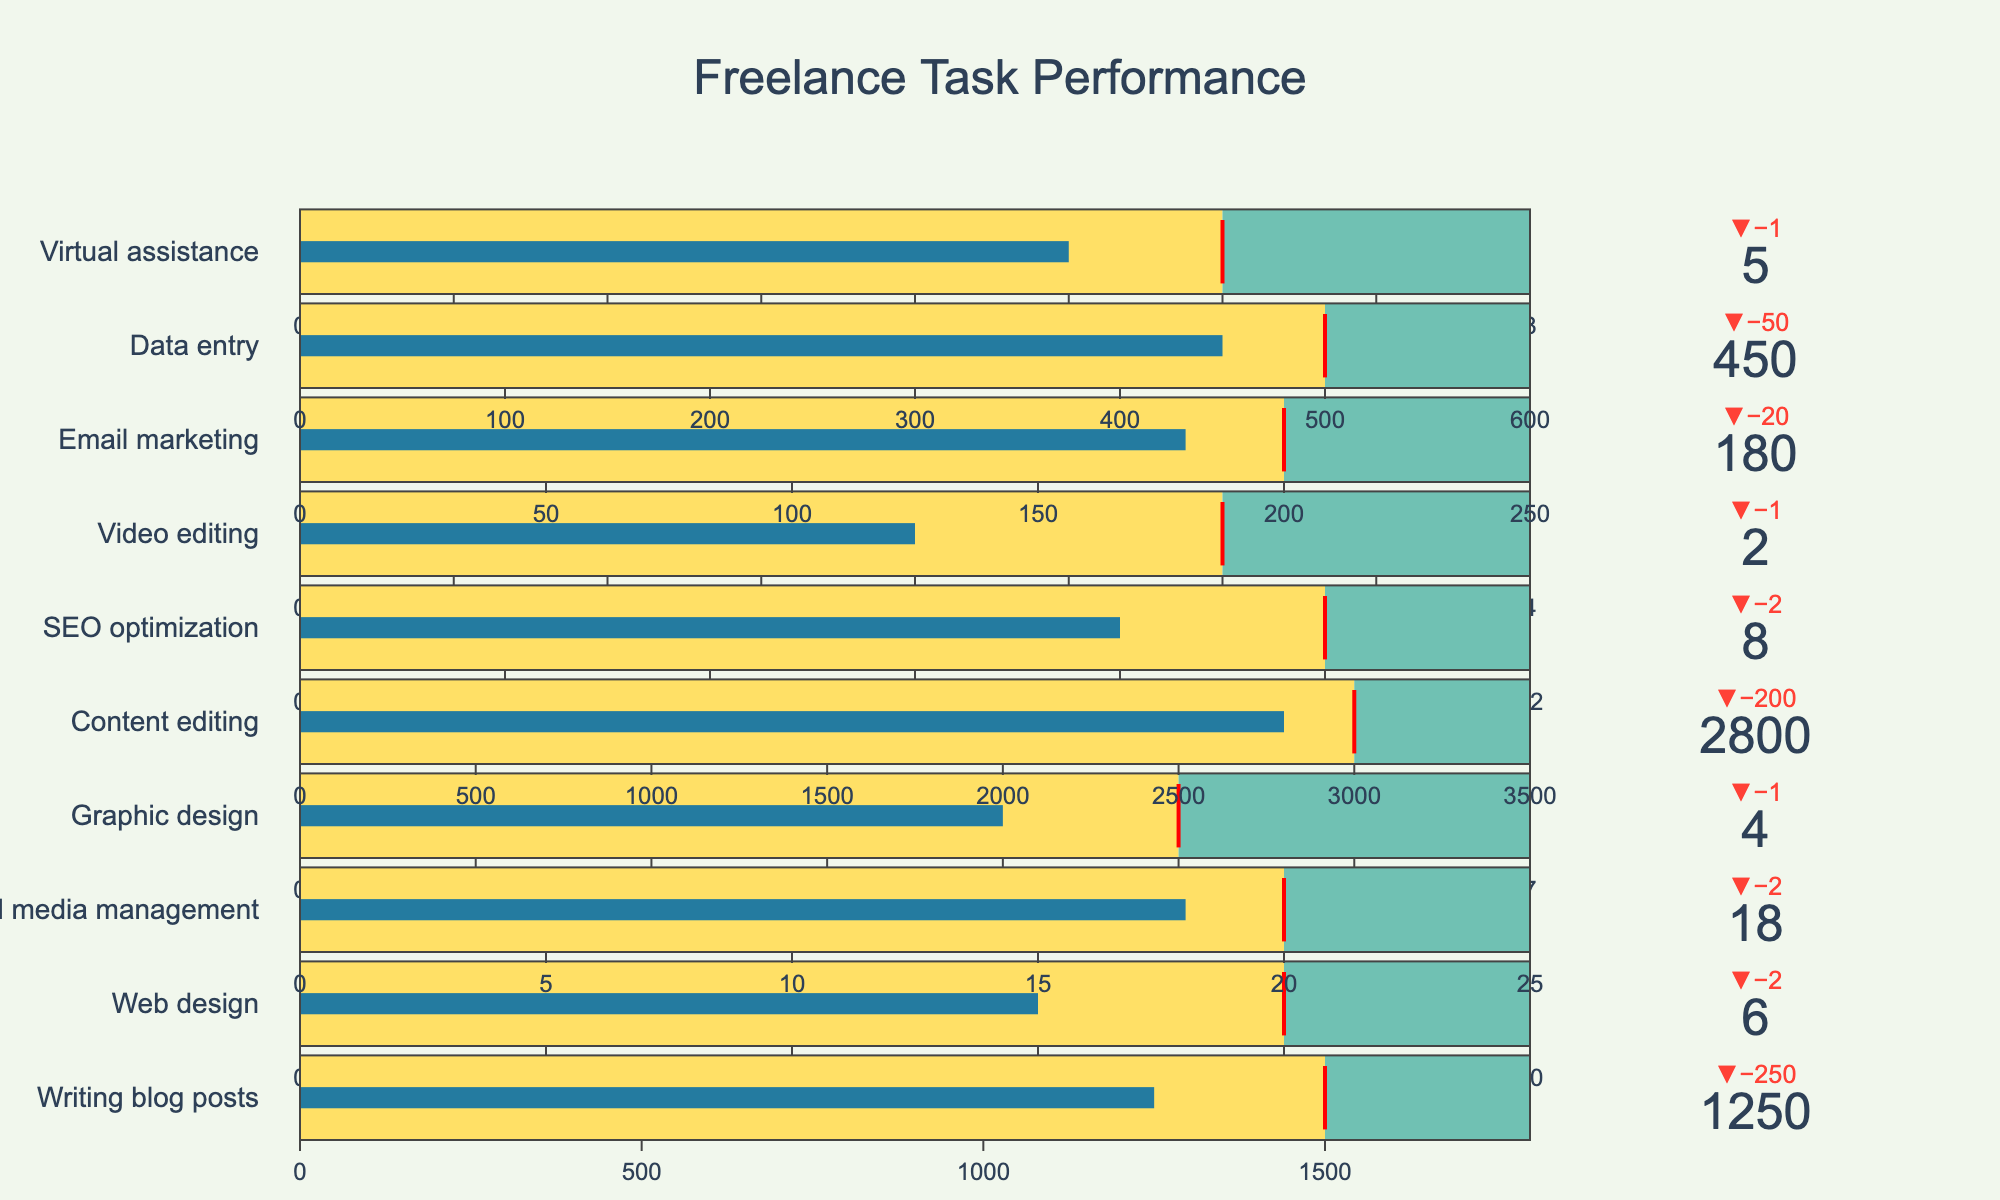what is the title of the chart? The title is generally found at the top of the chart, centered and in a larger font size. In this case, the title reads "Freelance Task Performance" as indicated in the given data.
Answer: Freelance Task Performance how many tasks are represented in this chart? By looking at the number of individual bullet graphs representing different tasks, one can count the total number of tasks shown. The chart has 10 tasks listed, as detailed in the data provided.
Answer: 10 which task has the smallest difference between actual performance and goal? By examining the “Delta” indicator for each task, which showcases the difference between actual performance and the goal, you can identify the task with the smallest difference. The task "Content editing" has the smallest difference, with an actual performance of 2800 against a goal of 3000.
Answer: Content editing what is the actual performance value for web design? This information is found within the bullet chart for Web Design, where the actual performance value would be listed. According to the data, the actual performance for Web Design is 6.
Answer: 6 how does the actual performance of graphic design compare to its benchmark? Looking at the bullet chart for Graphic Design, we see the benchmark value is 7, and the actual performance is 4. The actual performance is thus 3 units below the benchmark.
Answer: 3 units below which task has the largest discrepancy between the goal and actual performance? By comparing the “Delta” indicator values for all tasks, the task with the largest discrepancy can be identified. Here, the largest negative delta is for "Video editing," where the actual performance is 2, and the goal is 3.
Answer: Video editing what color is used to show the steps between actual performance and benchmarks? Steps in bullet charts are often represented with distinct colors. The provided data states that the color between the goal and benchmark is "#70C1B3", which is a shade of teal.
Answer: Teal what tasks are above their goal performance? By identifying tasks whose actual performance exceeds their goal, we refer to the delta indicators that show positive values. The data shows no tasks with actual values surpassing their goals.
Answer: None what is the position of the delta indicator? The delta indicator's position is given in the description of the bullet chart structure. According to the code, the delta indicator is positioned at the top.
Answer: Top 